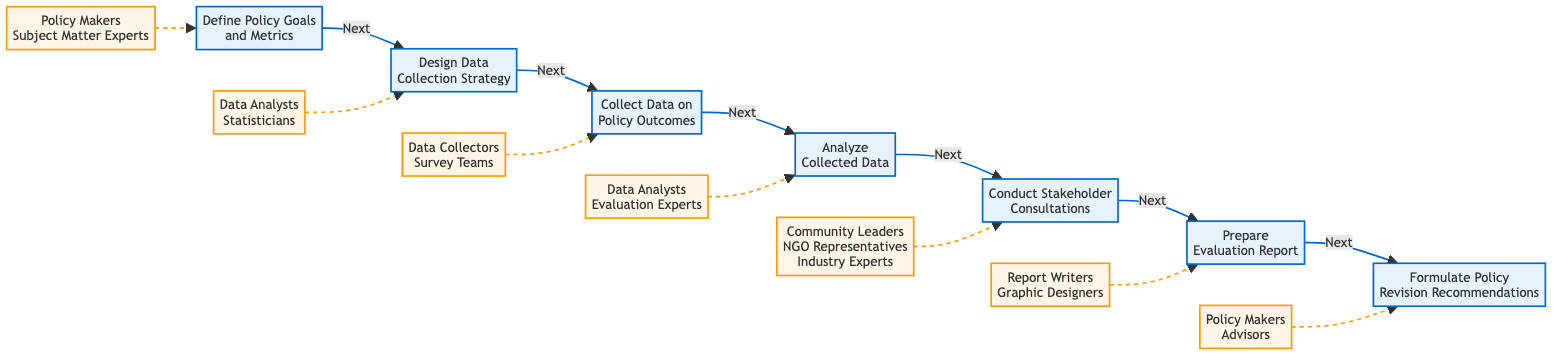What is the first step in the policy impact evaluation procedure? The first step is "Define Policy Goals and Metrics," which is the initial point of the flowchart, indicating it starts with establishing goals and success metrics.
Answer: Define Policy Goals and Metrics How many steps are there in this evaluation process? Counting all the steps represented in the diagram, there are a total of 7 distinct steps listed that describe the procedure for policy impact evaluation.
Answer: 7 Which participants are involved in the "Conduct Stakeholder Consultations" step? The diagram specifies that the participants for this step include "Community Leaders," "NGO Representatives," and "Industry Experts," who contribute feedback during consultations.
Answer: Community Leaders, NGO Representatives, Industry Experts What is the relationship between "Analyze Collected Data" and "Conduct Stakeholder Consultations"? The flowchart indicates that "Analyze Collected Data" is a preceding step to "Conduct Stakeholder Consultations," showing that data analysis occurs before engaging with stakeholders.
Answer: Analyze Collected Data comes before Conduct Stakeholder Consultations What is the last step in the flowchart? The final step outlined in the flowchart is "Formulate Policy Revision Recommendations," marking the end point of the evaluation process.
Answer: Formulate Policy Revision Recommendations Which step comes directly after "Collect Data on Policy Outcomes"? After the "Collect Data on Policy Outcomes" step, the next step is "Analyze Collected Data," indicating that analysis follows data collection.
Answer: Analyze Collected Data List the key participants involved in the "Prepare Evaluation Report" step. According to the diagram, the key participants for this step are "Report Writers" and "Graphic Designers," who work on compiling findings into the report.
Answer: Report Writers, Graphic Designers How do "Data Analysts" contribute throughout the evaluation process? "Data Analysts" are involved in two key steps: they participate in "Design Data Collection Strategy" and also in "Analyze Collected Data," showing their role in both planning and analysis phases of the evaluation.
Answer: Design Data Collection Strategy, Analyze Collected Data What type of flowchart is being described in this diagram? The diagram is classified as a "horizontal flowchart," which illustrates a sequential process from left to right, depicting steps in the policy impact evaluation procedure.
Answer: Horizontal flowchart 